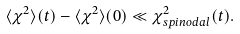Convert formula to latex. <formula><loc_0><loc_0><loc_500><loc_500>\langle \chi ^ { 2 } \rangle ( t ) - \langle \chi ^ { 2 } \rangle ( 0 ) \ll \chi ^ { 2 } _ { s p i n o d a l } ( t ) .</formula> 